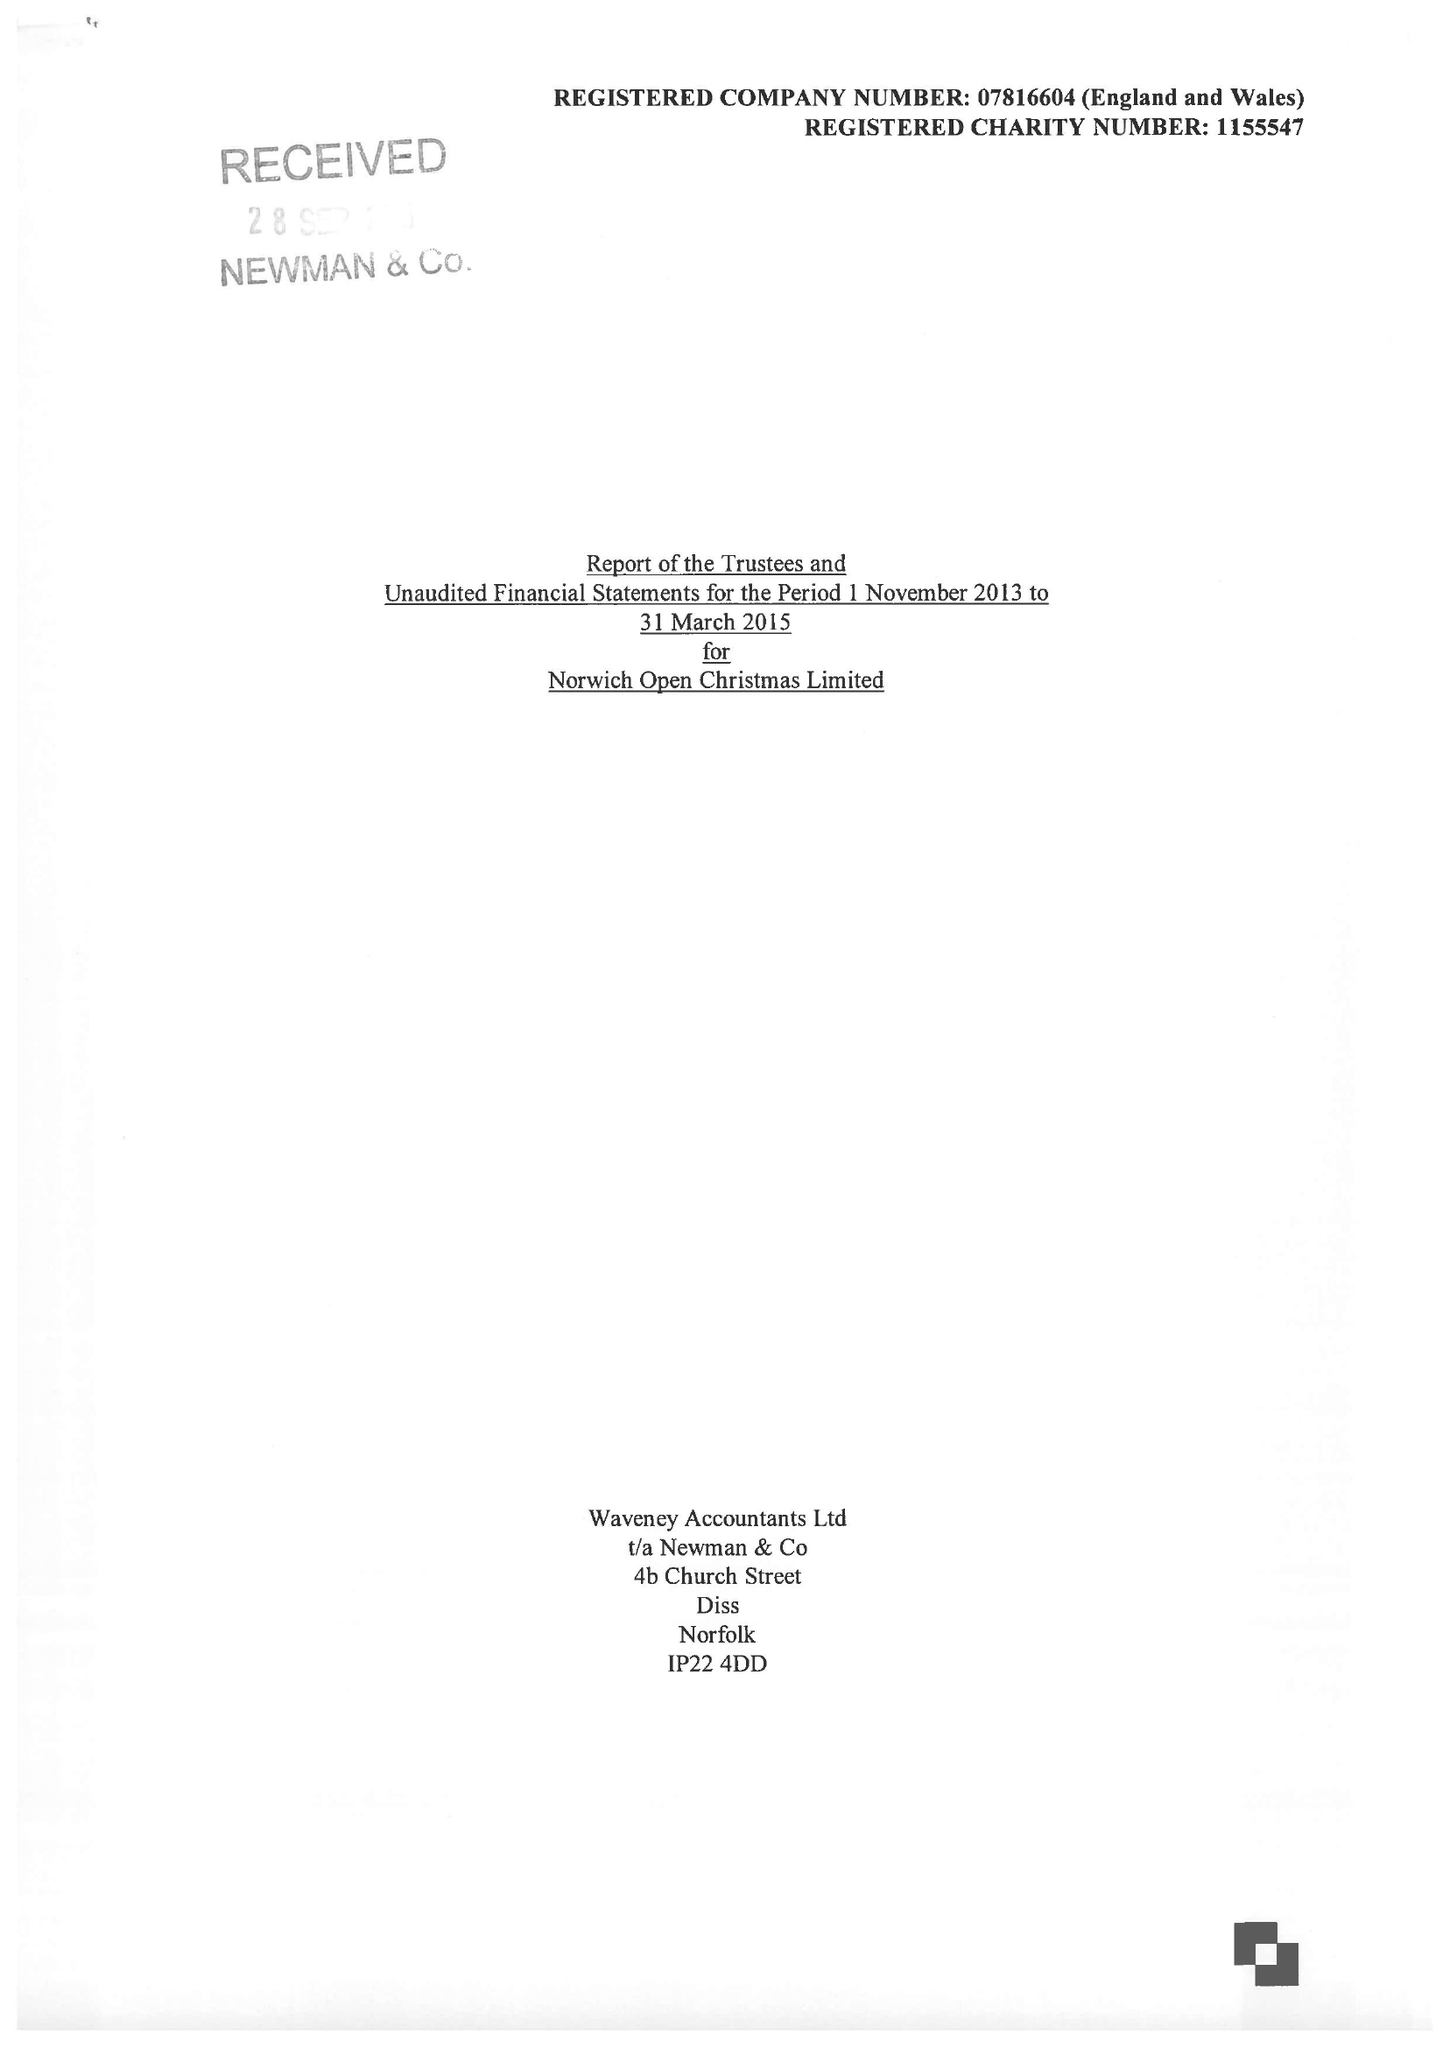What is the value for the address__street_line?
Answer the question using a single word or phrase. 27A THE STREET 